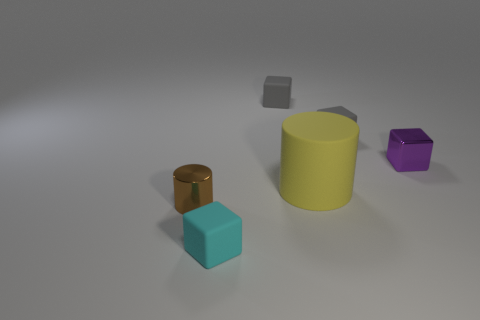Add 3 cyan things. How many objects exist? 9 Subtract all cylinders. How many objects are left? 4 Subtract all gray matte things. Subtract all big yellow rubber cylinders. How many objects are left? 3 Add 6 shiny things. How many shiny things are left? 8 Add 2 blue metal balls. How many blue metal balls exist? 2 Subtract 0 yellow blocks. How many objects are left? 6 